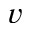<formula> <loc_0><loc_0><loc_500><loc_500>v</formula> 